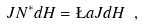Convert formula to latex. <formula><loc_0><loc_0><loc_500><loc_500>J N ^ { * } d H = \L a J d H \ ,</formula> 